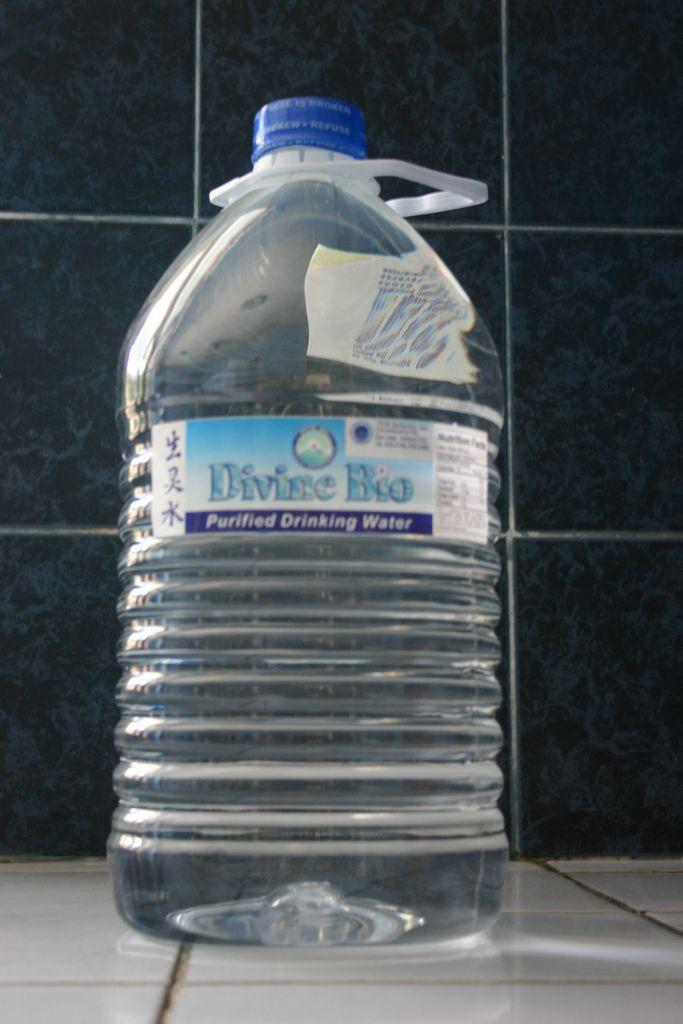Provide a one-sentence caption for the provided image. A big bottle of Divine Bio purified drinking water. 